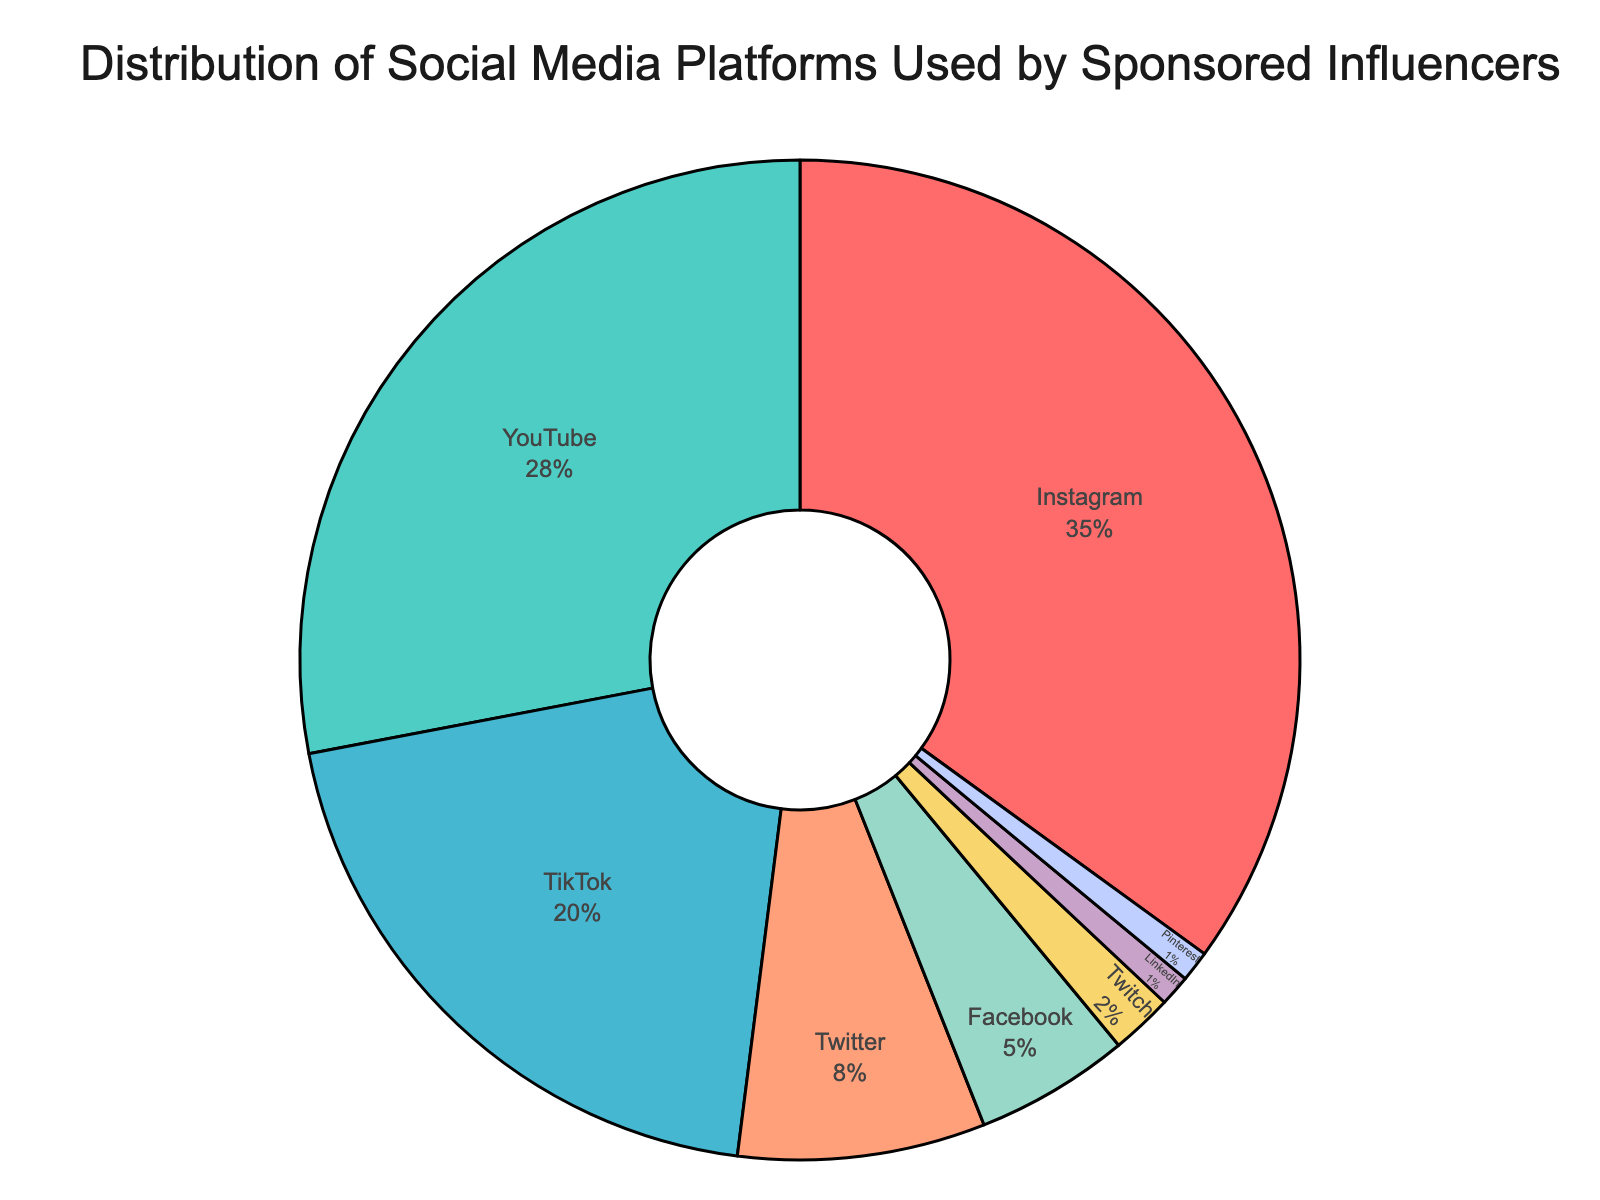What percentage of sponsored influencers use Instagram? Look at the percentage labeled for Instagram in the pie chart.
Answer: 35% Which platform is used by the least number of sponsored influencers? Identify the segment with the smallest percentage in the pie chart.
Answer: Pinterest How much more popular is Instagram compared to TikTok among sponsored influencers? Subtract the percentage of TikTok from the percentage of Instagram.
Answer: 15% What proportion of sponsored influencers use YouTube or Twitter combined? Add the percentages for YouTube and Twitter together.
Answer: 36% Is YouTube or TikTok more popular among sponsored influencers? Compare the percentages labeled for YouTube and TikTok.
Answer: YouTube Which color represents Twitch in the pie chart? Identify the color segment labeled as Twitch in the pie chart.
Answer: Greenish color What is the total percentage of sponsored influencers using Facebook, Twitch, LinkedIn, and Pinterest? Add the percentages for Facebook, Twitch, LinkedIn, and Pinterest.
Answer: 9% Which platforms together make up more than half of the distribution? Sum consecutive platform percentages until more than 50% is reached; Instagram (35%) + YouTube (28%) = 63%.
Answer: Instagram, YouTube How much more popular is Twitter compared to Facebook among sponsored influencers? Subtract the percentage of Facebook from the percentage of Twitter.
Answer: 3% What percentage of sponsored influencers use platforms other than Twitter and Facebook? Subtract the combined percentages of Twitter and Facebook from 100%.
Answer: 87% 